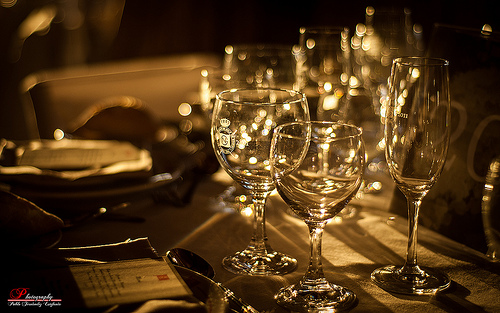<image>
Is the champagne glass in front of the wine glass? No. The champagne glass is not in front of the wine glass. The spatial positioning shows a different relationship between these objects. 